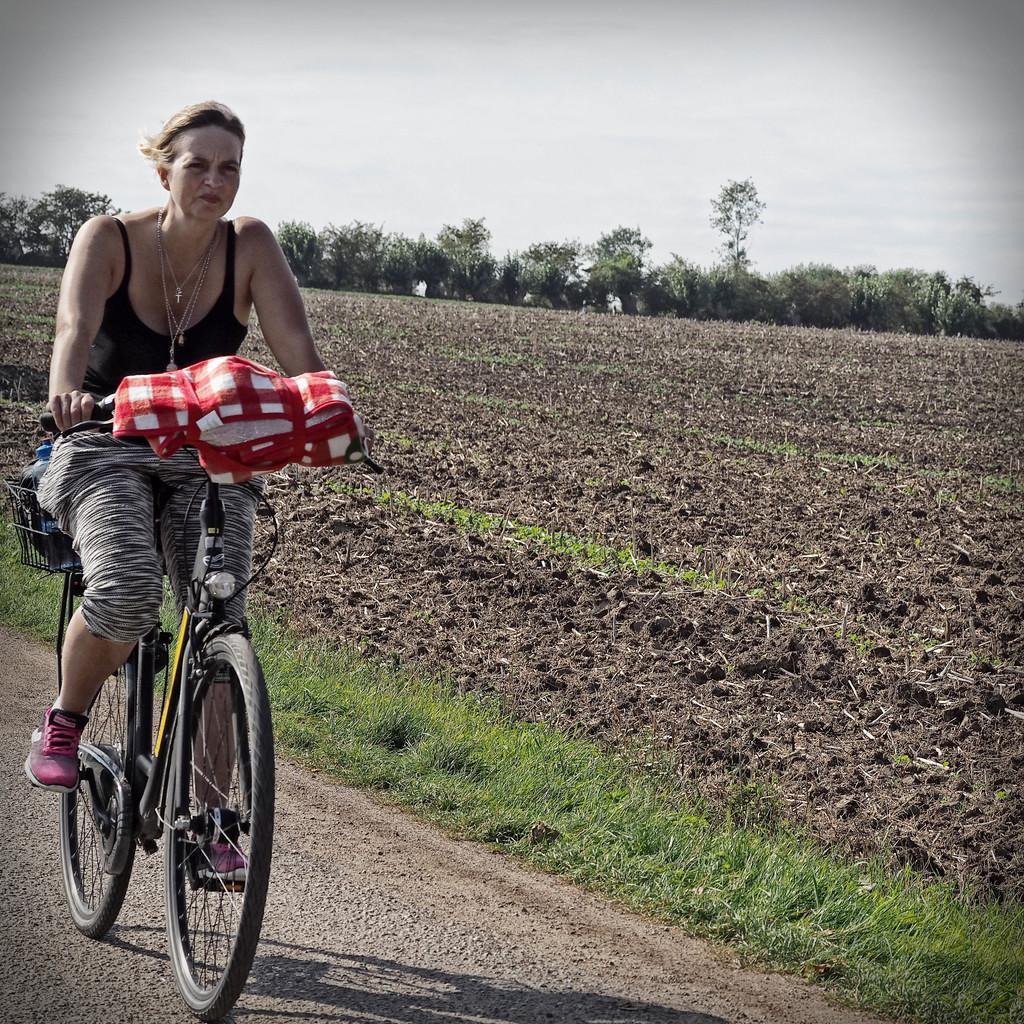Can you describe this image briefly? In this image, woman is riding a bicycle. There is a cloth on it. The back side, there is a basket. In that basket, we can see a bottle. Here we can see a farm land, here grass. The bottom, we can see a road. The background, few plants we can see and sky. 